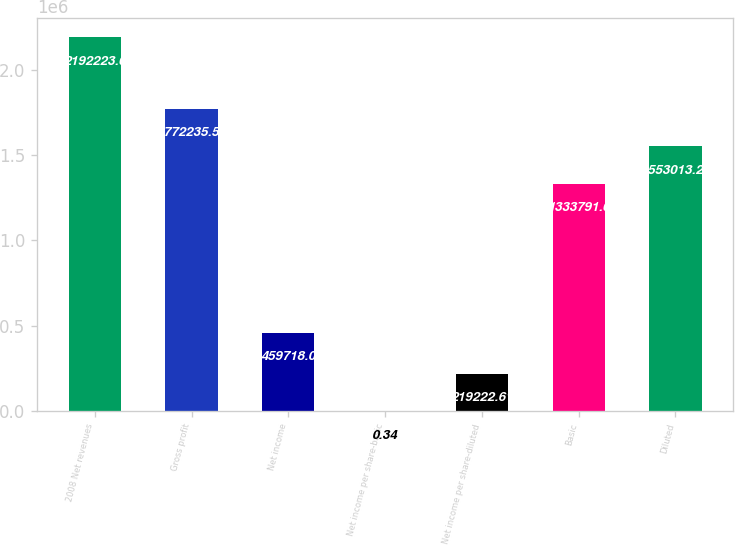Convert chart. <chart><loc_0><loc_0><loc_500><loc_500><bar_chart><fcel>2008 Net revenues<fcel>Gross profit<fcel>Net income<fcel>Net income per share-basic<fcel>Net income per share-diluted<fcel>Basic<fcel>Diluted<nl><fcel>2.19222e+06<fcel>1.77224e+06<fcel>459718<fcel>0.34<fcel>219223<fcel>1.33379e+06<fcel>1.55301e+06<nl></chart> 